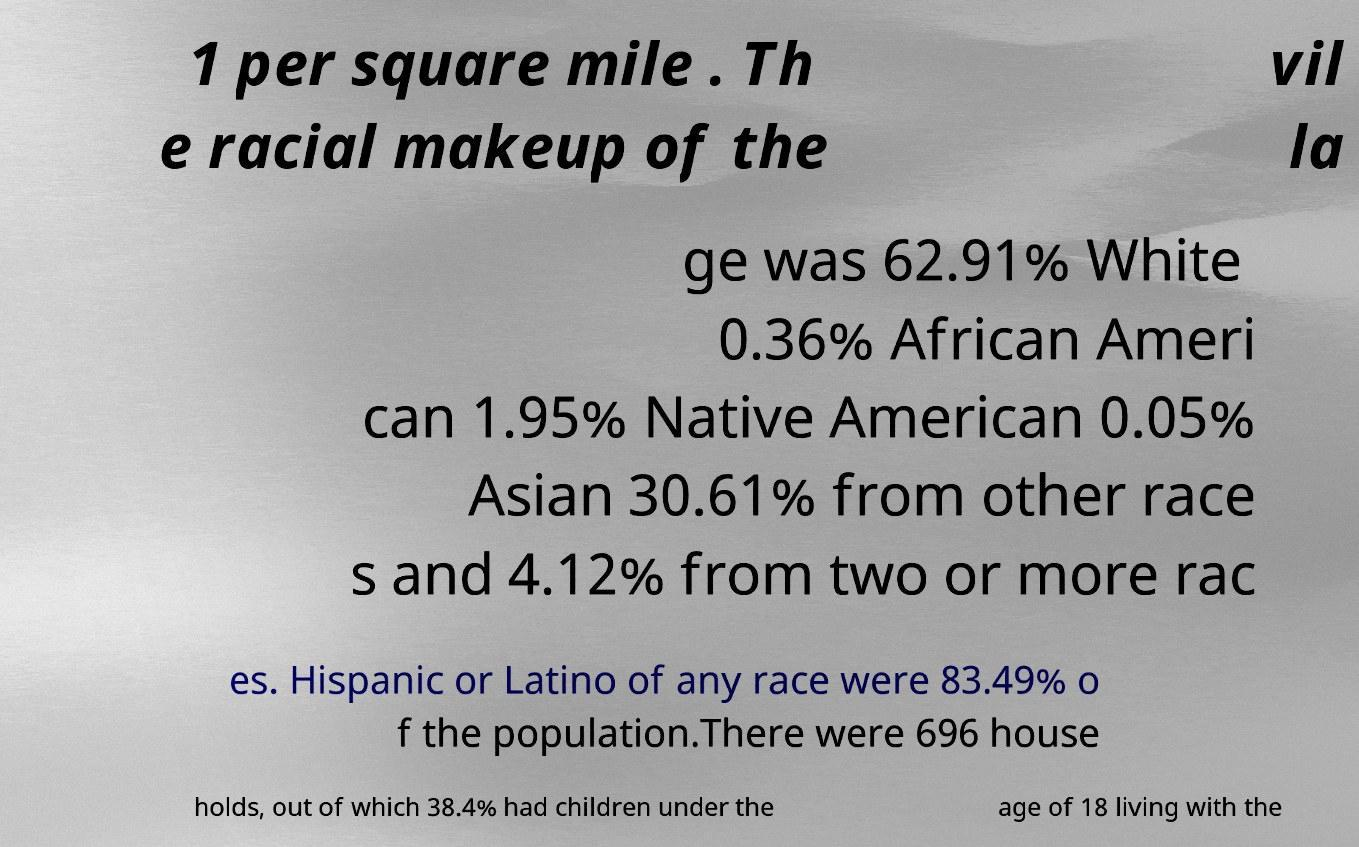I need the written content from this picture converted into text. Can you do that? 1 per square mile . Th e racial makeup of the vil la ge was 62.91% White 0.36% African Ameri can 1.95% Native American 0.05% Asian 30.61% from other race s and 4.12% from two or more rac es. Hispanic or Latino of any race were 83.49% o f the population.There were 696 house holds, out of which 38.4% had children under the age of 18 living with the 